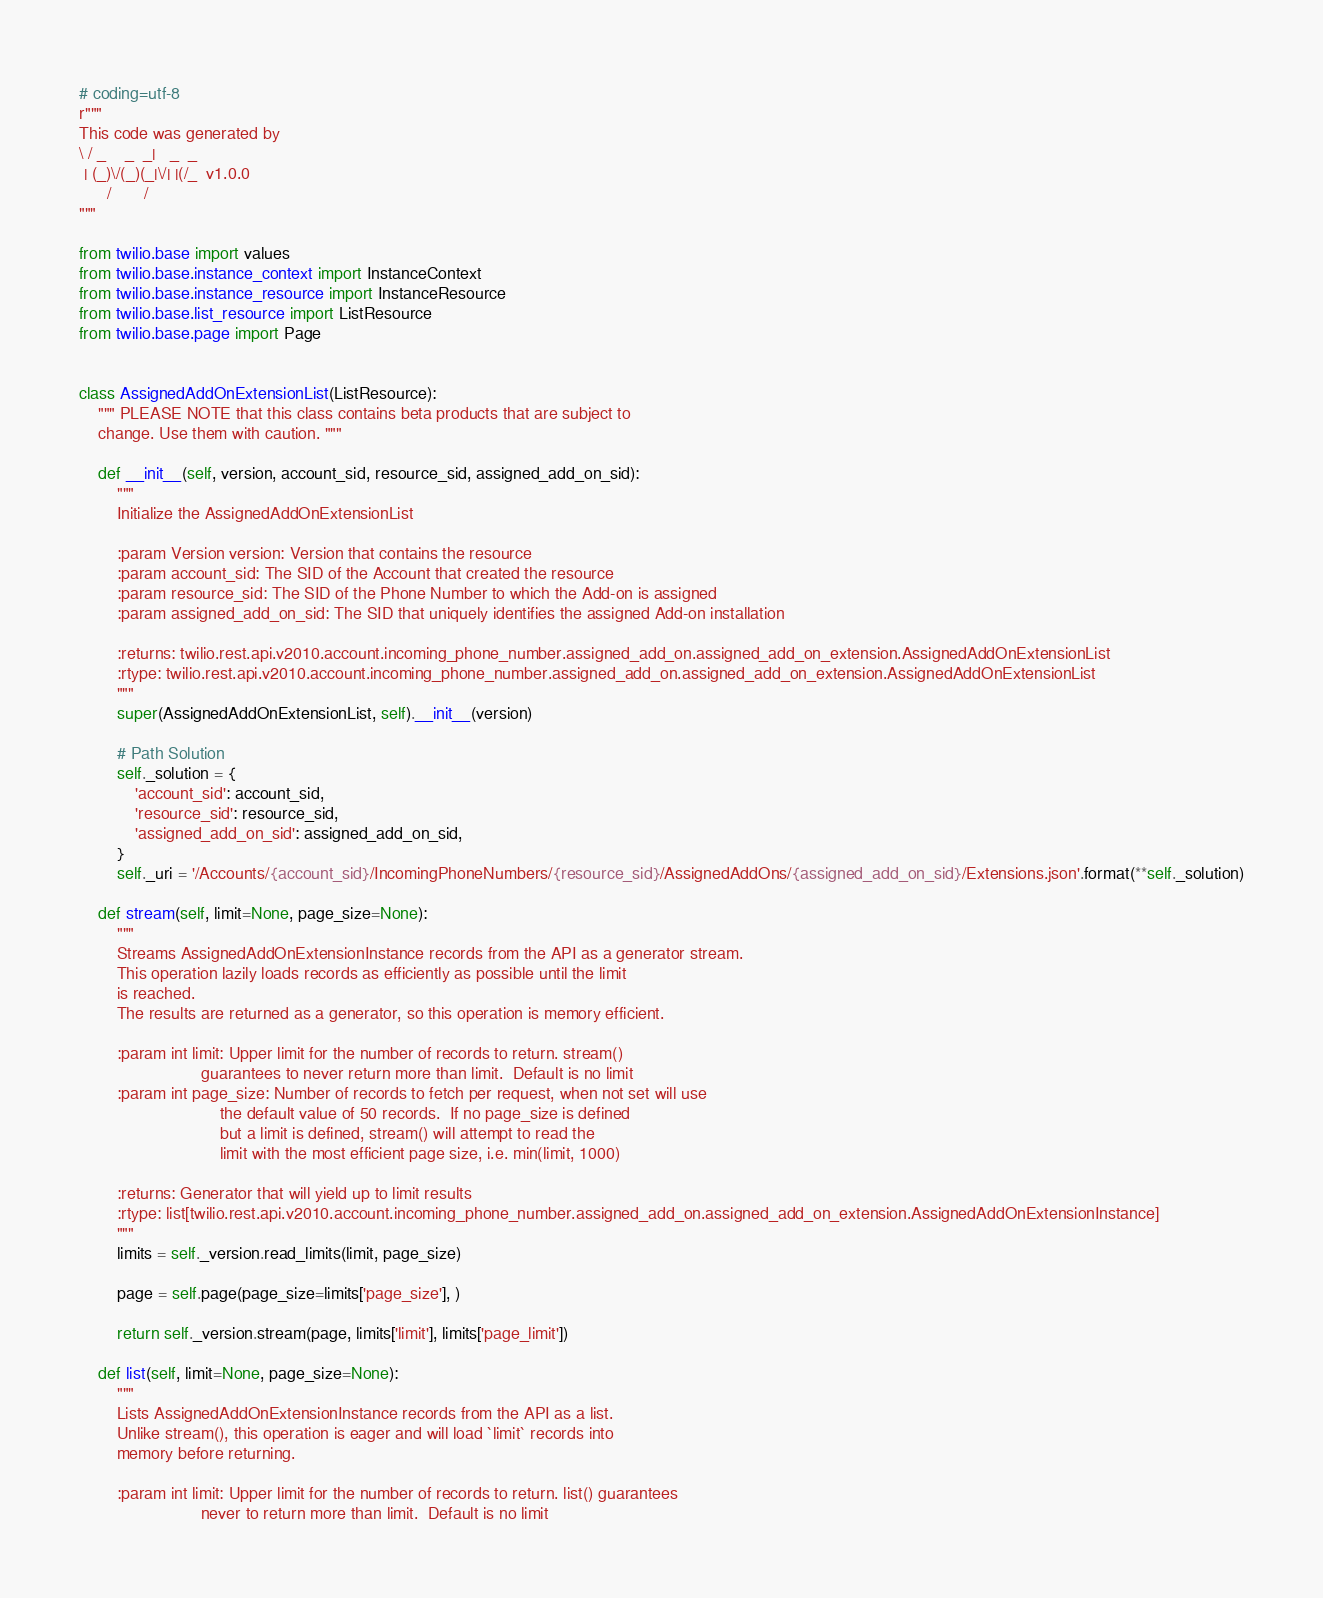<code> <loc_0><loc_0><loc_500><loc_500><_Python_># coding=utf-8
r"""
This code was generated by
\ / _    _  _|   _  _
 | (_)\/(_)(_|\/| |(/_  v1.0.0
      /       /
"""

from twilio.base import values
from twilio.base.instance_context import InstanceContext
from twilio.base.instance_resource import InstanceResource
from twilio.base.list_resource import ListResource
from twilio.base.page import Page


class AssignedAddOnExtensionList(ListResource):
    """ PLEASE NOTE that this class contains beta products that are subject to
    change. Use them with caution. """

    def __init__(self, version, account_sid, resource_sid, assigned_add_on_sid):
        """
        Initialize the AssignedAddOnExtensionList

        :param Version version: Version that contains the resource
        :param account_sid: The SID of the Account that created the resource
        :param resource_sid: The SID of the Phone Number to which the Add-on is assigned
        :param assigned_add_on_sid: The SID that uniquely identifies the assigned Add-on installation

        :returns: twilio.rest.api.v2010.account.incoming_phone_number.assigned_add_on.assigned_add_on_extension.AssignedAddOnExtensionList
        :rtype: twilio.rest.api.v2010.account.incoming_phone_number.assigned_add_on.assigned_add_on_extension.AssignedAddOnExtensionList
        """
        super(AssignedAddOnExtensionList, self).__init__(version)

        # Path Solution
        self._solution = {
            'account_sid': account_sid,
            'resource_sid': resource_sid,
            'assigned_add_on_sid': assigned_add_on_sid,
        }
        self._uri = '/Accounts/{account_sid}/IncomingPhoneNumbers/{resource_sid}/AssignedAddOns/{assigned_add_on_sid}/Extensions.json'.format(**self._solution)

    def stream(self, limit=None, page_size=None):
        """
        Streams AssignedAddOnExtensionInstance records from the API as a generator stream.
        This operation lazily loads records as efficiently as possible until the limit
        is reached.
        The results are returned as a generator, so this operation is memory efficient.

        :param int limit: Upper limit for the number of records to return. stream()
                          guarantees to never return more than limit.  Default is no limit
        :param int page_size: Number of records to fetch per request, when not set will use
                              the default value of 50 records.  If no page_size is defined
                              but a limit is defined, stream() will attempt to read the
                              limit with the most efficient page size, i.e. min(limit, 1000)

        :returns: Generator that will yield up to limit results
        :rtype: list[twilio.rest.api.v2010.account.incoming_phone_number.assigned_add_on.assigned_add_on_extension.AssignedAddOnExtensionInstance]
        """
        limits = self._version.read_limits(limit, page_size)

        page = self.page(page_size=limits['page_size'], )

        return self._version.stream(page, limits['limit'], limits['page_limit'])

    def list(self, limit=None, page_size=None):
        """
        Lists AssignedAddOnExtensionInstance records from the API as a list.
        Unlike stream(), this operation is eager and will load `limit` records into
        memory before returning.

        :param int limit: Upper limit for the number of records to return. list() guarantees
                          never to return more than limit.  Default is no limit</code> 